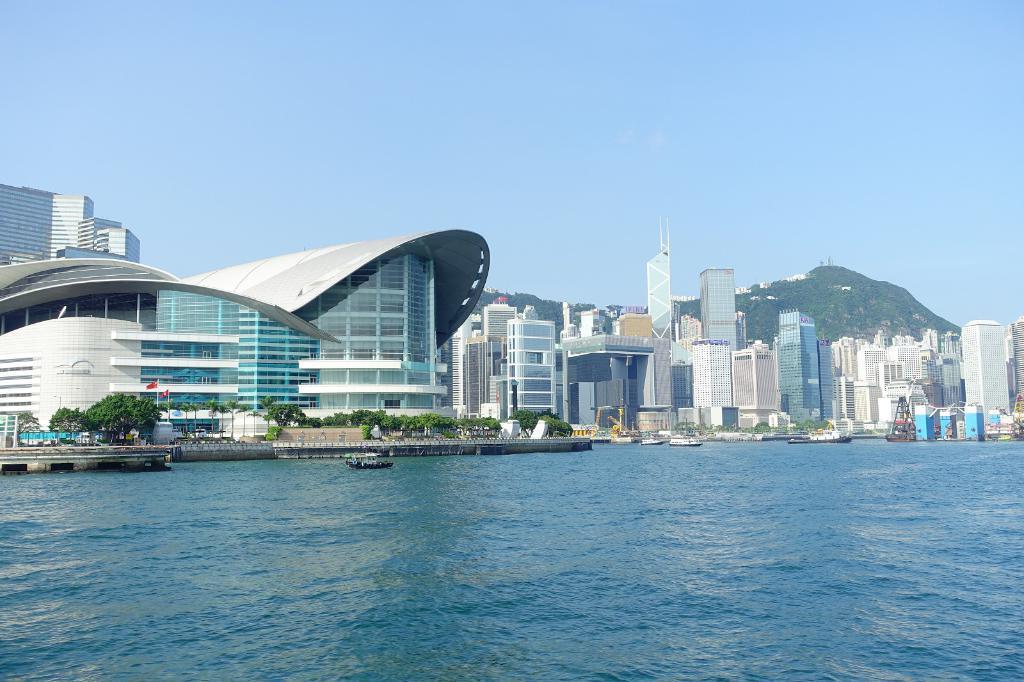Describe this image in one or two sentences. Here in this picture, in the front we can see water present over a place and we can also see boats present and on the ground we can see buildings present and we can also see plants and trees present and in the far we can see mountains that are covered with grass and plants and we can see the sky is clear. 